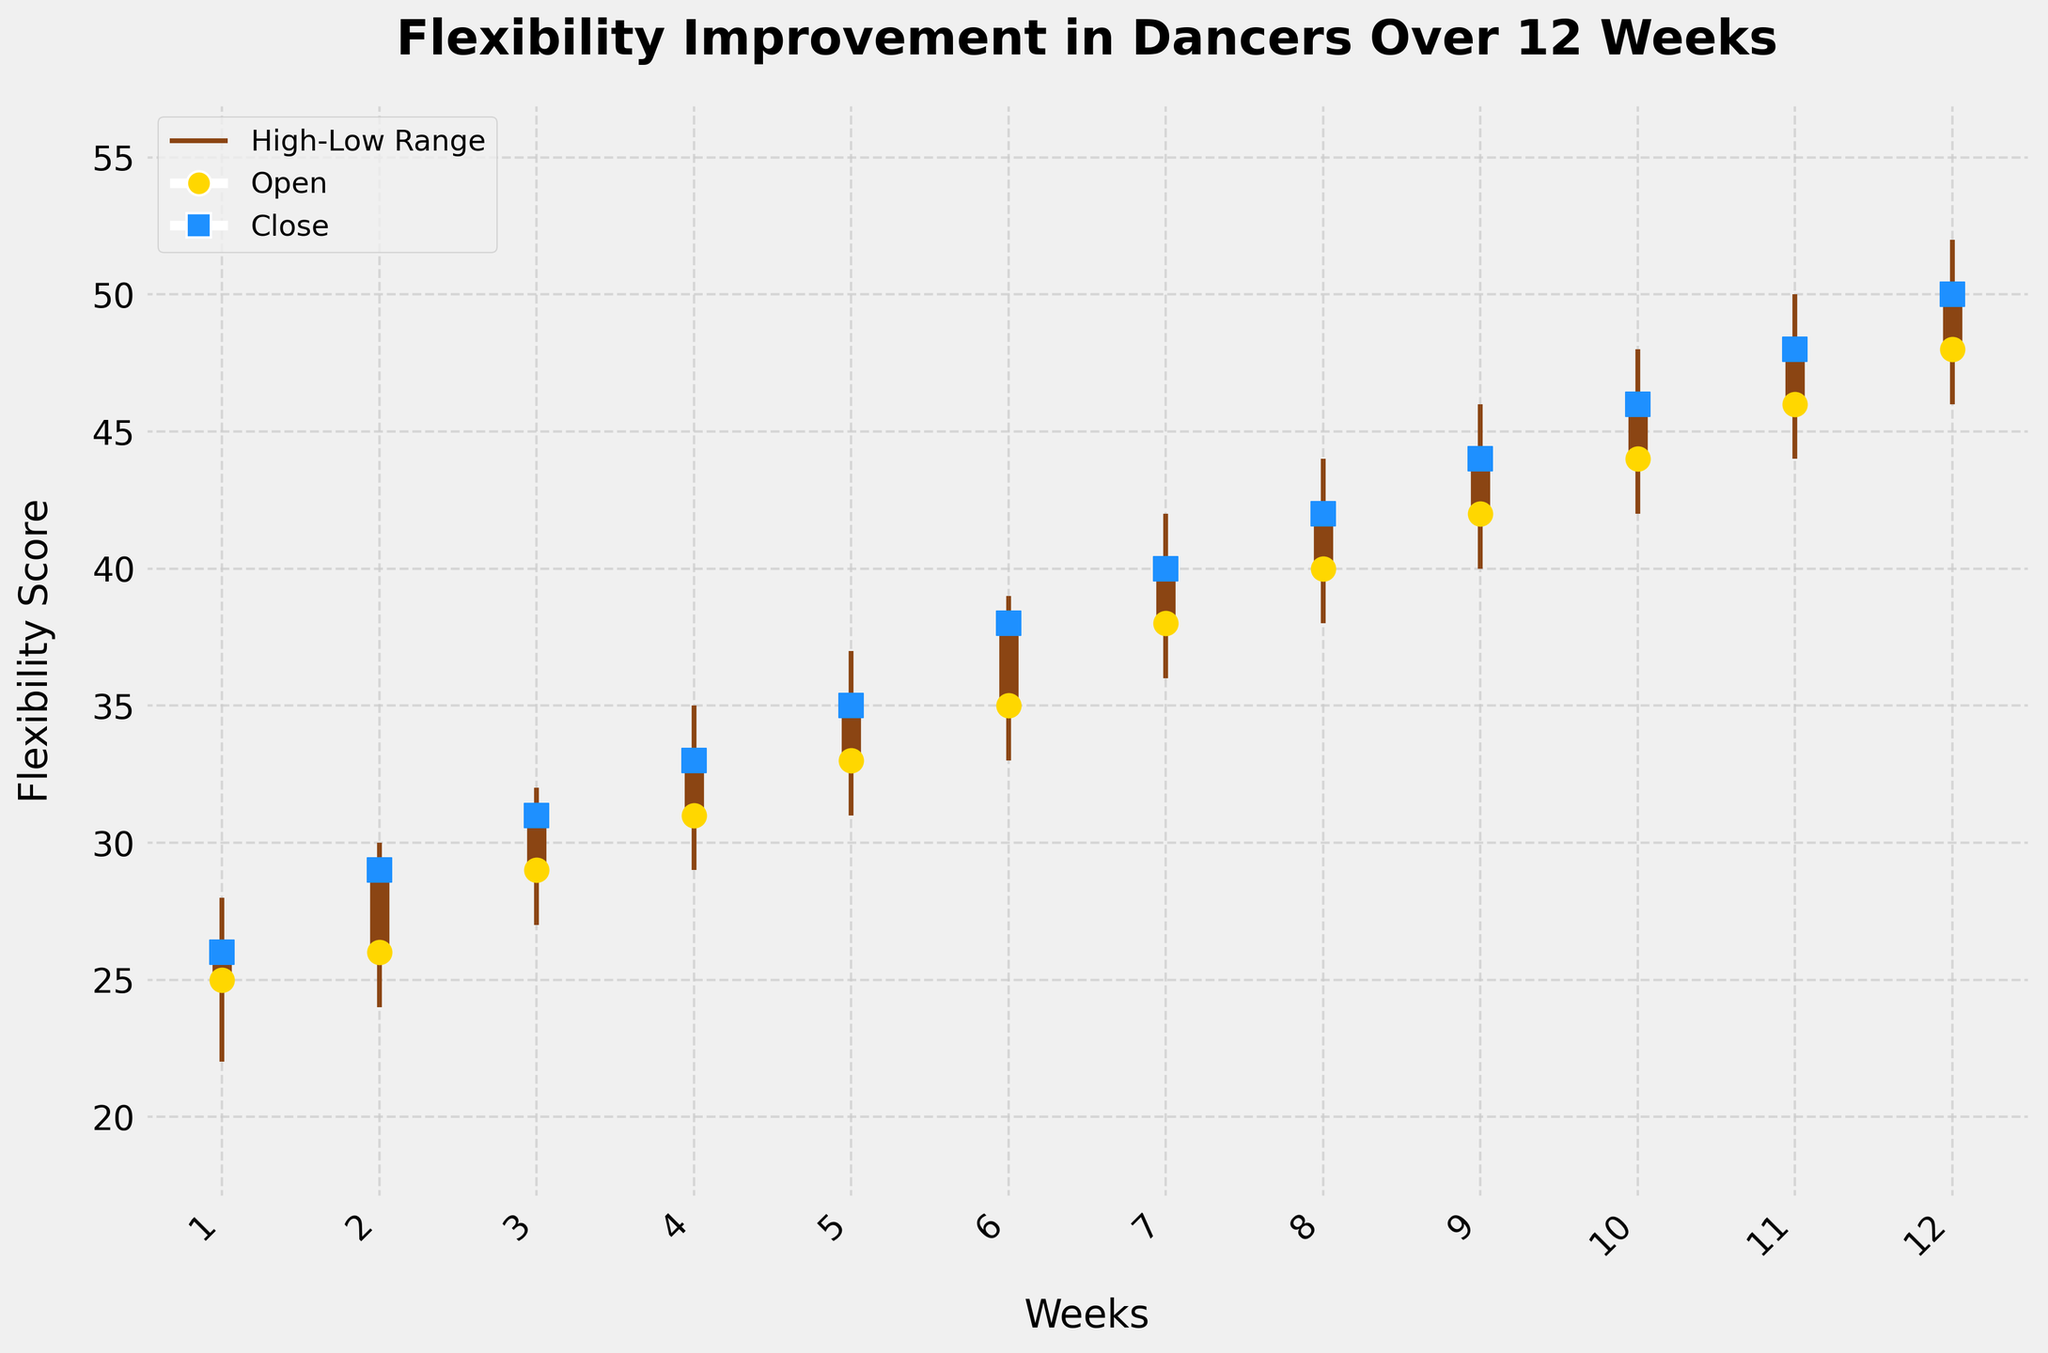What's the title of the figure? The title of the figure is clearly positioned at the top of the plot in a larger, bold font. It reads, "Flexibility Improvement in Dancers Over 12 Weeks".
Answer: Flexibility Improvement in Dancers Over 12 Weeks What are the labels of the x and y axes? The labels are positioned at the ends of the x and y axes. The x-axis is labeled "Weeks", and the y-axis is labeled "Flexibility Score".
Answer: Weeks and Flexibility Score How many weeks does the data cover? The x-axis ticks and the labels indicate that the data spans from week 1 to week 12.
Answer: 12 weeks What are the colors used for the Open and Close markers? The plot shows yellow circles for Open values and blue squares for Close values.
Answer: Yellow for Open and Blue for Close Between which weeks is the greatest weekly improvement in flexibility observed? Observing the distance between the Open and Close markers, the largest improvement occurs between weeks 11 and 12 where the Close jumps 2 points higher than the previous week's Close.
Answer: Weeks 11 to 12 What is the average Close value over the 12 weeks? Sum all Close values (26 + 29 + 31 + 33 + 35 + 38 + 40 + 42 + 44 + 46 + 48 + 50) to get 462, then divide by 12 weeks: 462 / 12 = 38.5.
Answer: 38.5 Which week had the smallest difference between High and Low values? By inspecting the lengths of the High-Low ranges, we find that week 3 had the smallest range, which is 5 points (32 - 27).
Answer: Week 3 What is the overall trend observed in the flexibility scores from week 1 to week 12? Week by week, the Open and Close values generally increase steadily, showing an overall upward trend in flexibility improvement across the 12 weeks.
Answer: Upward trend Is there any week where the Close value decreased compared to the previous week? Comparing week to week, all Close values show either an increase or consistent improvement; there are no decreases between weeks.
Answer: No In which week does the Close value first reach 40 or more? The Close reaches 40 for the first time at week 7, as denoted by the blue square marker.
Answer: Week 7 